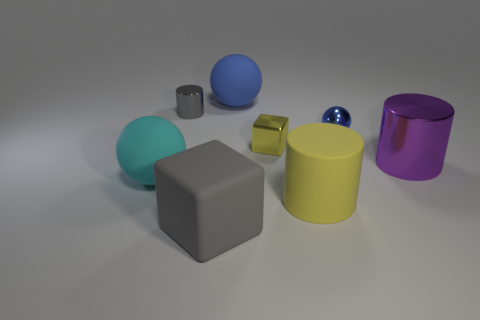Is the matte cube the same color as the large matte cylinder?
Keep it short and to the point. No. How many other metallic cubes are the same color as the big cube?
Offer a terse response. 0. What size is the cube that is in front of the shiny cylinder that is on the right side of the small gray shiny cylinder?
Your response must be concise. Large. There is a tiny gray metallic object; what shape is it?
Provide a succinct answer. Cylinder. There is a large ball that is on the left side of the gray cube; what is its material?
Your response must be concise. Rubber. There is a small shiny thing on the left side of the large rubber object that is behind the big rubber ball that is on the left side of the blue rubber object; what color is it?
Provide a short and direct response. Gray. What color is the metallic thing that is the same size as the gray rubber thing?
Provide a succinct answer. Purple. How many metallic things are spheres or large blocks?
Give a very brief answer. 1. What is the color of the small block that is the same material as the gray cylinder?
Your answer should be very brief. Yellow. What is the material of the gray object that is in front of the sphere that is on the left side of the gray rubber block?
Offer a very short reply. Rubber. 